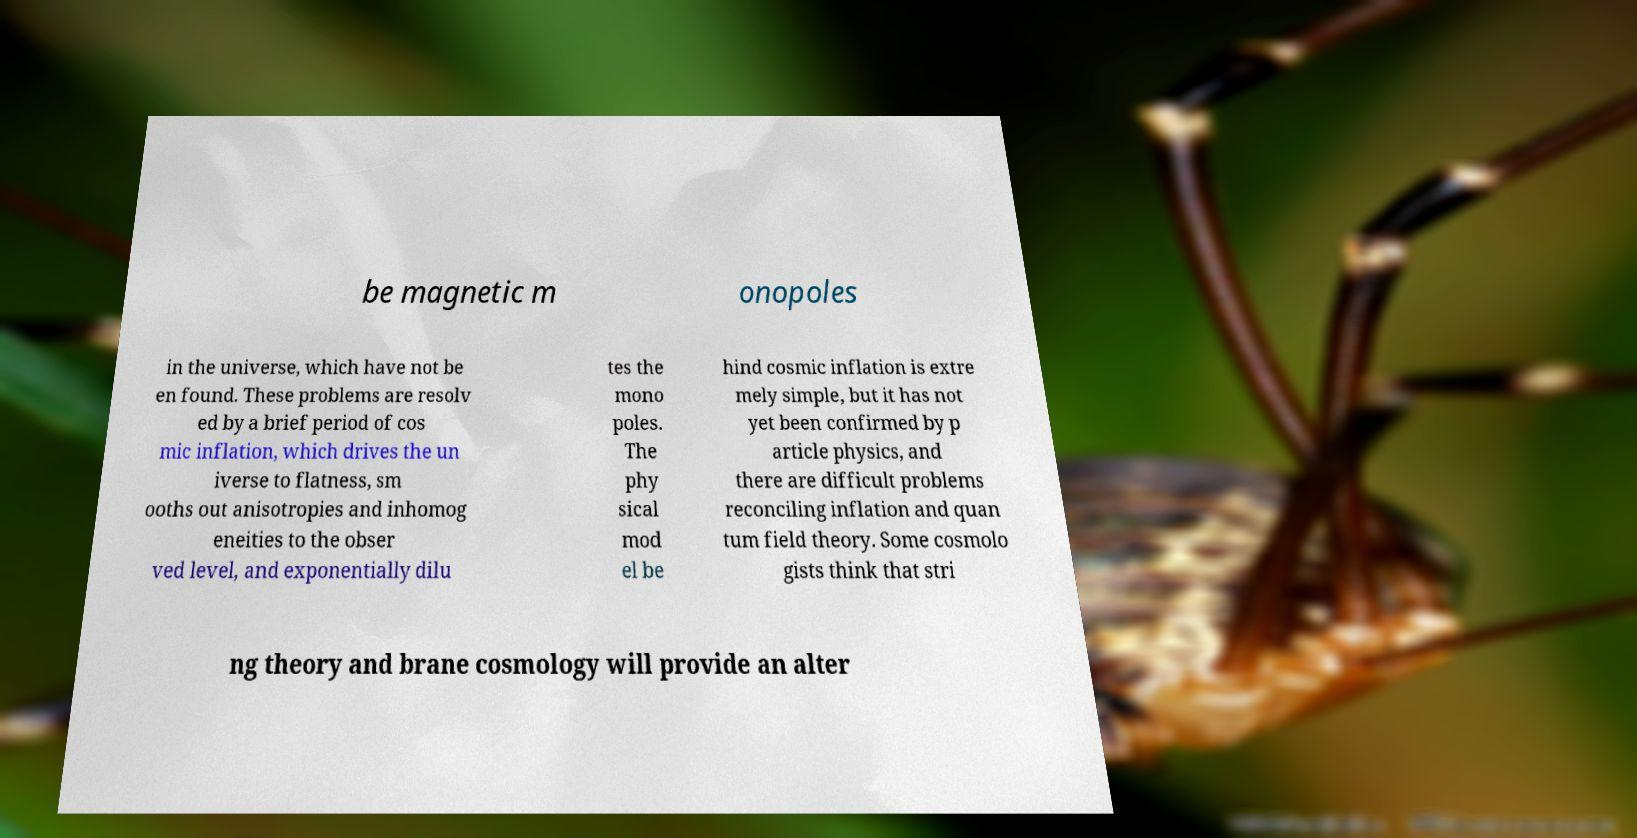For documentation purposes, I need the text within this image transcribed. Could you provide that? be magnetic m onopoles in the universe, which have not be en found. These problems are resolv ed by a brief period of cos mic inflation, which drives the un iverse to flatness, sm ooths out anisotropies and inhomog eneities to the obser ved level, and exponentially dilu tes the mono poles. The phy sical mod el be hind cosmic inflation is extre mely simple, but it has not yet been confirmed by p article physics, and there are difficult problems reconciling inflation and quan tum field theory. Some cosmolo gists think that stri ng theory and brane cosmology will provide an alter 